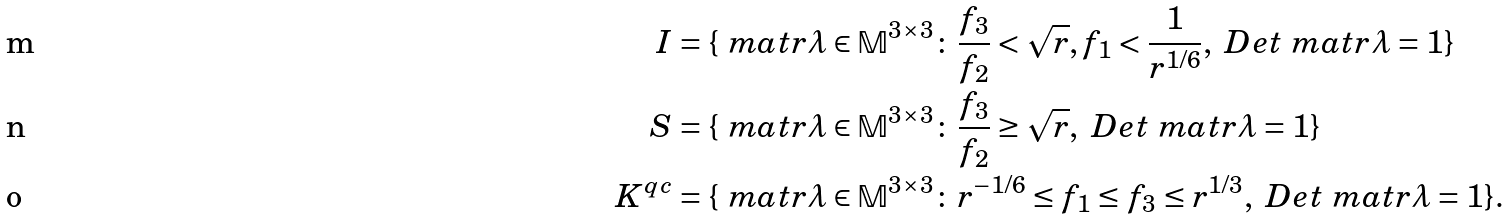<formula> <loc_0><loc_0><loc_500><loc_500>I & = \{ \ m a t r { \lambda } \in \mathbb { M } ^ { 3 \times 3 } \colon \frac { f _ { 3 } } { f _ { 2 } } < \sqrt { r } , f _ { 1 } < \frac { 1 } { r ^ { 1 / 6 } } , \ D e t { \ m a t r { \lambda } } = 1 \} \\ S & = \{ \ m a t r { \lambda } \in \mathbb { M } ^ { 3 \times 3 } \colon \frac { f _ { 3 } } { f _ { 2 } } \geq \sqrt { r } , \ D e t { \ m a t r { \lambda } } = 1 \} \\ K ^ { q c } & = \{ \ m a t r { \lambda } \in \mathbb { M } ^ { 3 \times 3 } \colon r ^ { - 1 / 6 } \leq f _ { 1 } \leq f _ { 3 } \leq r ^ { 1 / 3 } , \ D e t { \ m a t r { \lambda } } = 1 \} .</formula> 